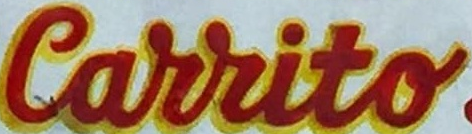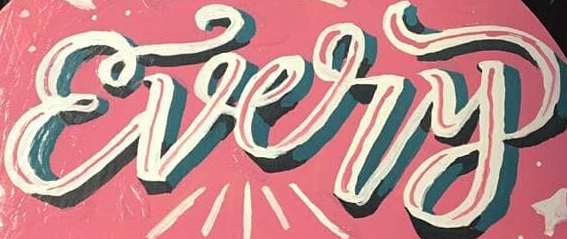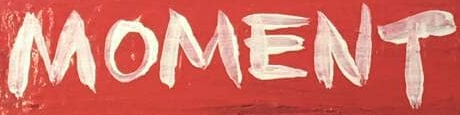Identify the words shown in these images in order, separated by a semicolon. Carrito; Every; MOMENT 